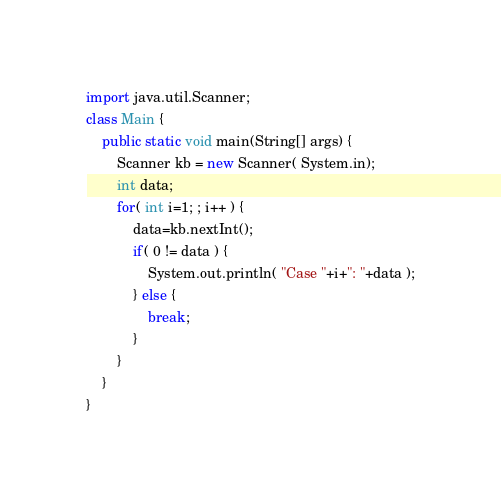Convert code to text. <code><loc_0><loc_0><loc_500><loc_500><_Java_>import java.util.Scanner;
class Main {
	public static void main(String[] args) {
		Scanner kb = new Scanner( System.in);	
		int data;
		for( int i=1; ; i++ ) {
			data=kb.nextInt();
			if( 0 != data ) {
				System.out.println( "Case "+i+": "+data );
			} else {
				break;
			}
		}
	}
}</code> 